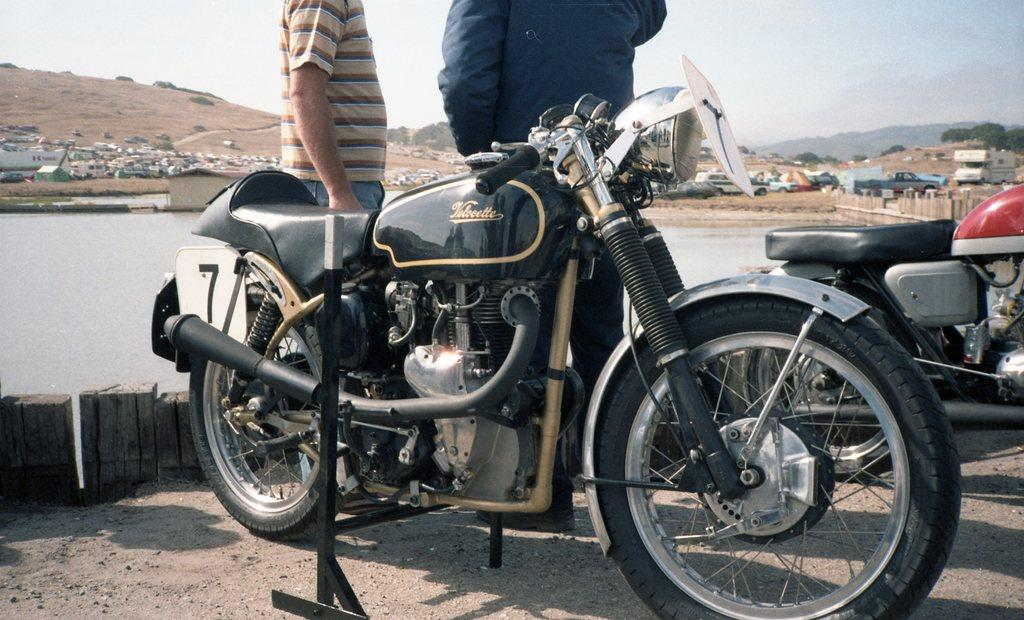What types of objects can be seen in the image? There are vehicles, a pole, trees, people, houses, mountains, and water visible in the image. What is the color of the sky in the image? The sky appears to be white in color. What type of landscape is depicted in the image? The image features a combination of natural and man-made elements, including trees, mountains, houses, and water. What is the tendency of the planes in the image? There are no planes present in the image. What is the end result of the water in the image? The image does not depict the end result of the water; it simply shows its presence. 